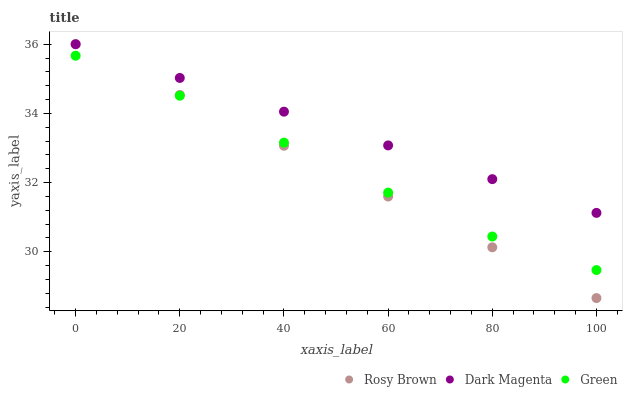Does Rosy Brown have the minimum area under the curve?
Answer yes or no. Yes. Does Dark Magenta have the maximum area under the curve?
Answer yes or no. Yes. Does Green have the minimum area under the curve?
Answer yes or no. No. Does Green have the maximum area under the curve?
Answer yes or no. No. Is Rosy Brown the smoothest?
Answer yes or no. Yes. Is Green the roughest?
Answer yes or no. Yes. Is Dark Magenta the smoothest?
Answer yes or no. No. Is Dark Magenta the roughest?
Answer yes or no. No. Does Rosy Brown have the lowest value?
Answer yes or no. Yes. Does Green have the lowest value?
Answer yes or no. No. Does Dark Magenta have the highest value?
Answer yes or no. Yes. Does Green have the highest value?
Answer yes or no. No. Is Green less than Dark Magenta?
Answer yes or no. Yes. Is Dark Magenta greater than Green?
Answer yes or no. Yes. Does Green intersect Rosy Brown?
Answer yes or no. Yes. Is Green less than Rosy Brown?
Answer yes or no. No. Is Green greater than Rosy Brown?
Answer yes or no. No. Does Green intersect Dark Magenta?
Answer yes or no. No. 